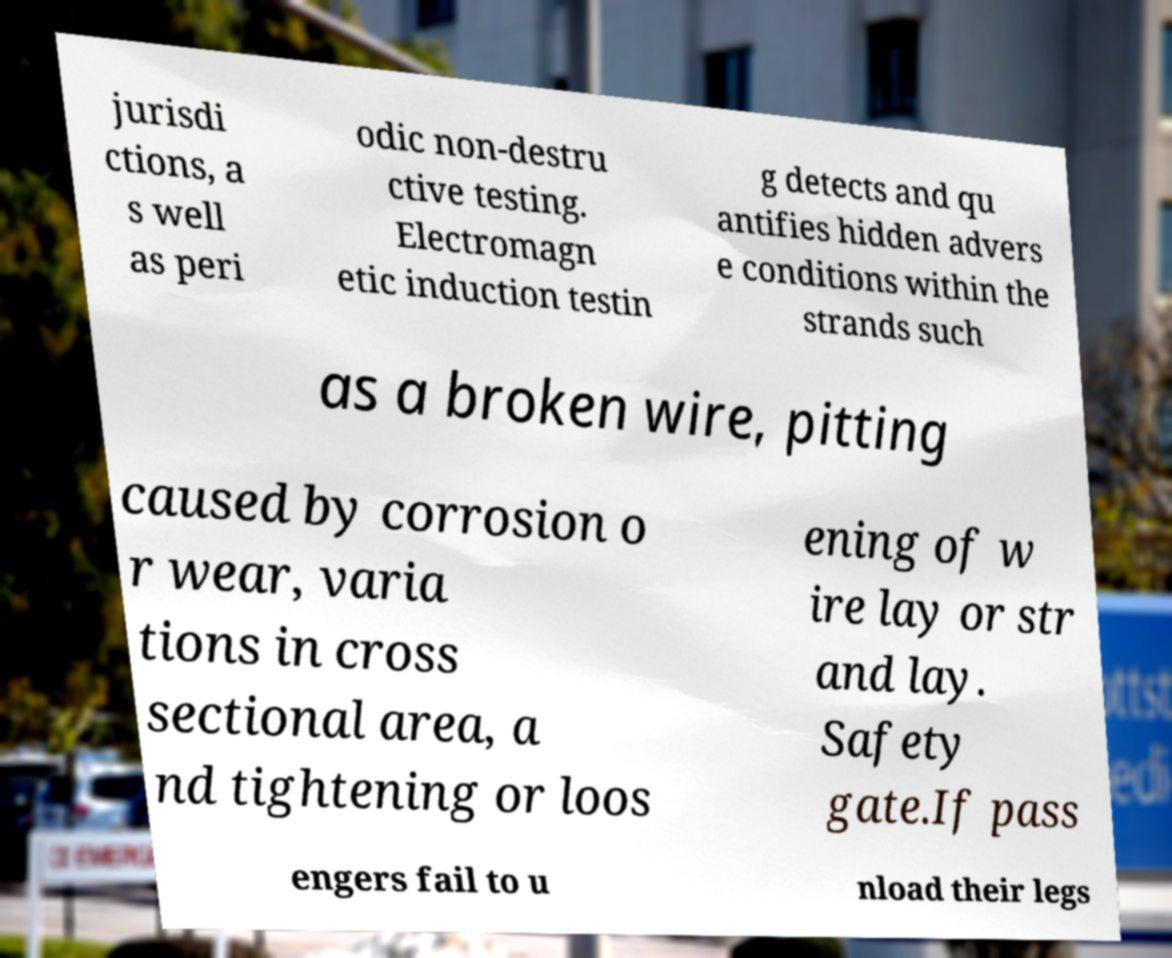Could you extract and type out the text from this image? jurisdi ctions, a s well as peri odic non-destru ctive testing. Electromagn etic induction testin g detects and qu antifies hidden advers e conditions within the strands such as a broken wire, pitting caused by corrosion o r wear, varia tions in cross sectional area, a nd tightening or loos ening of w ire lay or str and lay. Safety gate.If pass engers fail to u nload their legs 